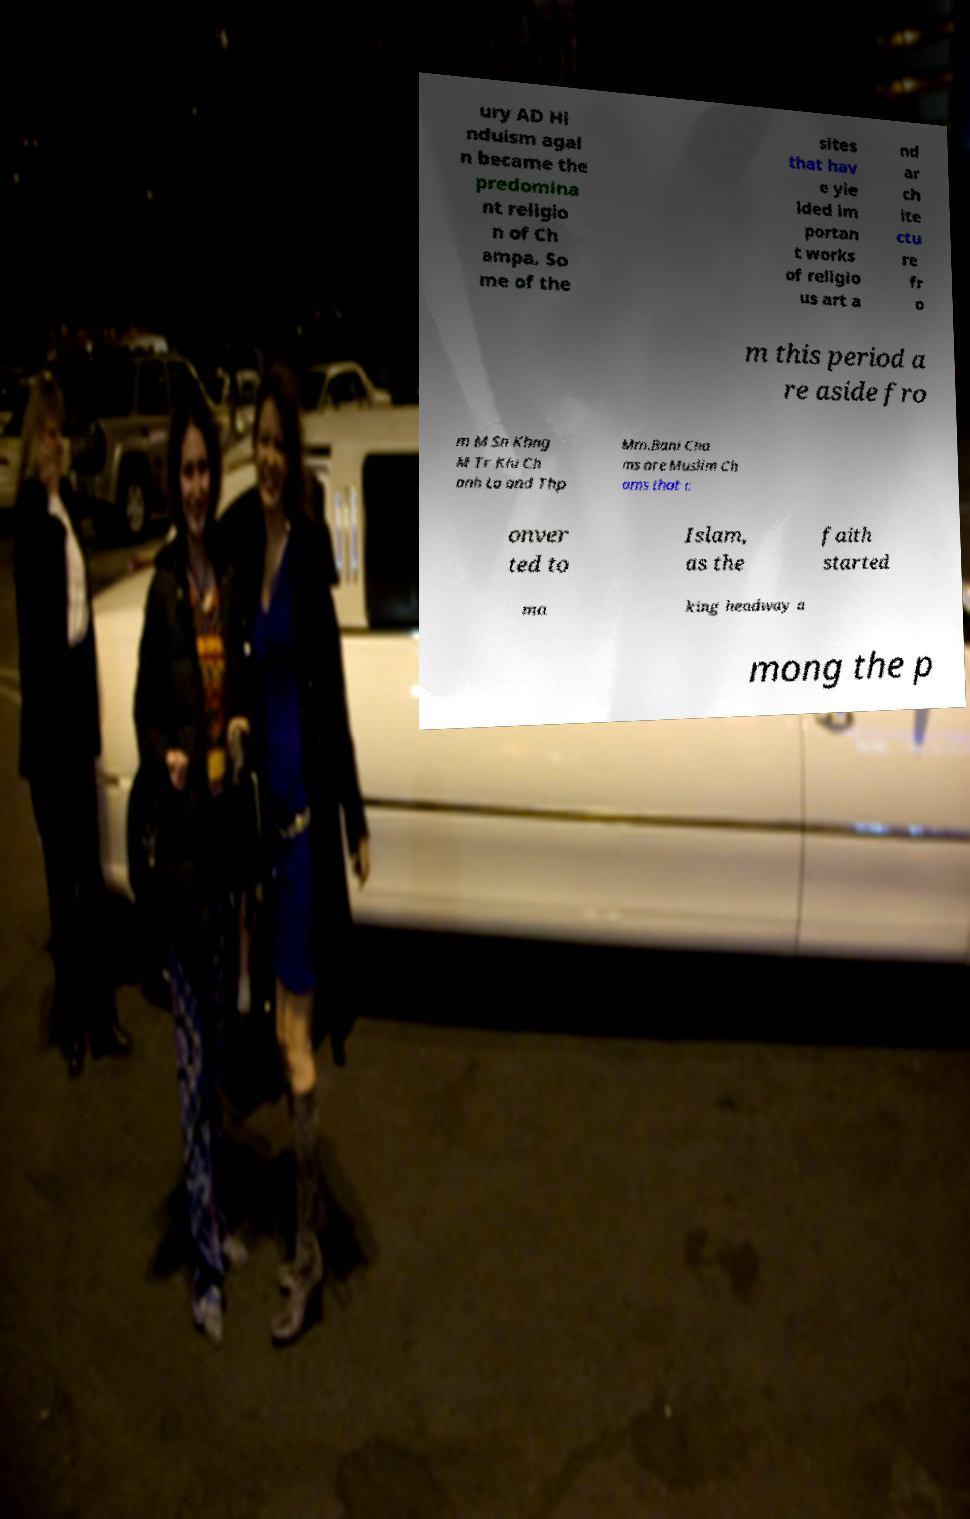I need the written content from this picture converted into text. Can you do that? ury AD Hi nduism agai n became the predomina nt religio n of Ch ampa. So me of the sites that hav e yie lded im portan t works of religio us art a nd ar ch ite ctu re fr o m this period a re aside fro m M Sn Khng M Tr Kiu Ch anh Lo and Thp Mm.Bani Cha ms are Muslim Ch ams that c onver ted to Islam, as the faith started ma king headway a mong the p 